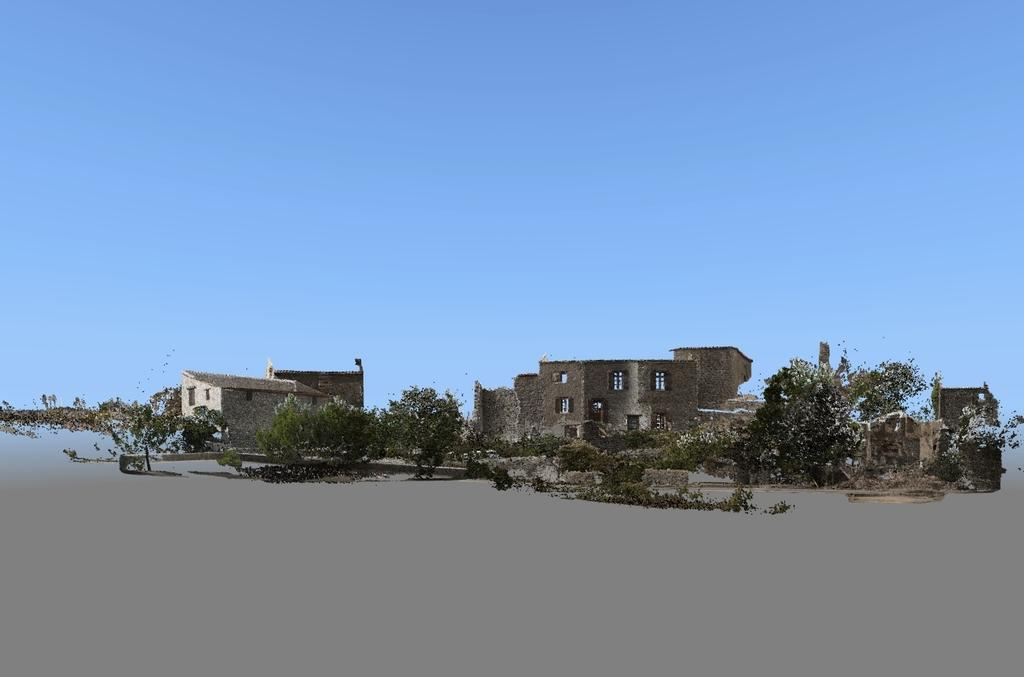What type of natural elements are present in the image? The image contains trees. What type of man-made structures are present in the image? The image contains buildings with windows. What is visible at the top of the image? The sky is visible at the top of the image. What type of discussion is taking place at the desk in the image? There is no desk present in the image, so it is not possible to determine if a discussion is taking place. 